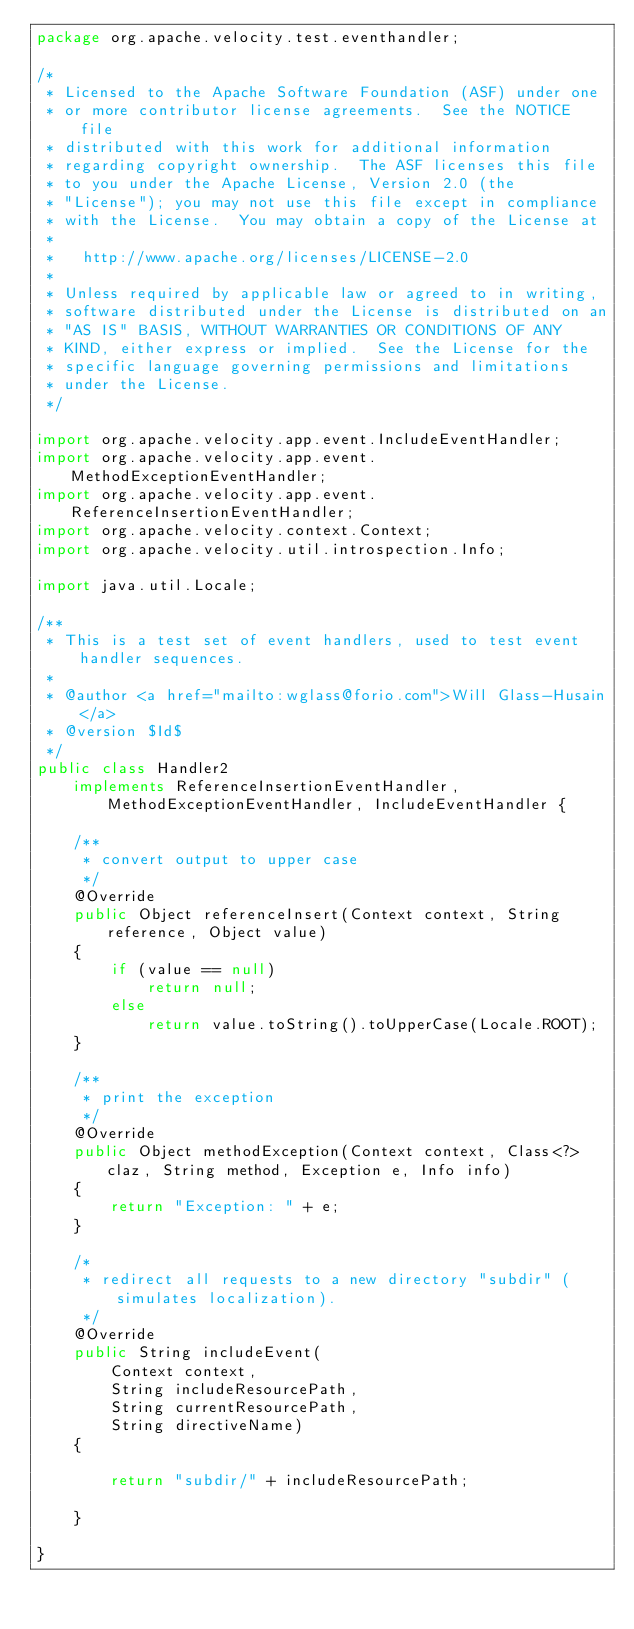Convert code to text. <code><loc_0><loc_0><loc_500><loc_500><_Java_>package org.apache.velocity.test.eventhandler;

/*
 * Licensed to the Apache Software Foundation (ASF) under one
 * or more contributor license agreements.  See the NOTICE file
 * distributed with this work for additional information
 * regarding copyright ownership.  The ASF licenses this file
 * to you under the Apache License, Version 2.0 (the
 * "License"); you may not use this file except in compliance
 * with the License.  You may obtain a copy of the License at
 *
 *   http://www.apache.org/licenses/LICENSE-2.0
 *
 * Unless required by applicable law or agreed to in writing,
 * software distributed under the License is distributed on an
 * "AS IS" BASIS, WITHOUT WARRANTIES OR CONDITIONS OF ANY
 * KIND, either express or implied.  See the License for the
 * specific language governing permissions and limitations
 * under the License.
 */

import org.apache.velocity.app.event.IncludeEventHandler;
import org.apache.velocity.app.event.MethodExceptionEventHandler;
import org.apache.velocity.app.event.ReferenceInsertionEventHandler;
import org.apache.velocity.context.Context;
import org.apache.velocity.util.introspection.Info;

import java.util.Locale;

/**
 * This is a test set of event handlers, used to test event handler sequences.
 *
 * @author <a href="mailto:wglass@forio.com">Will Glass-Husain</a>
 * @version $Id$
 */
public class Handler2
    implements ReferenceInsertionEventHandler, MethodExceptionEventHandler, IncludeEventHandler {

    /**
     * convert output to upper case
     */
    @Override
    public Object referenceInsert(Context context, String reference, Object value)
    {
        if (value == null)
            return null;
        else
            return value.toString().toUpperCase(Locale.ROOT);
    }

    /**
     * print the exception
     */
    @Override
    public Object methodException(Context context, Class<?> claz, String method, Exception e, Info info)
    {
        return "Exception: " + e;
    }

    /*
     * redirect all requests to a new directory "subdir" (simulates localization).
     */
    @Override
    public String includeEvent(
        Context context,
        String includeResourcePath,
        String currentResourcePath,
        String directiveName)
    {

        return "subdir/" + includeResourcePath;

    }

}
</code> 